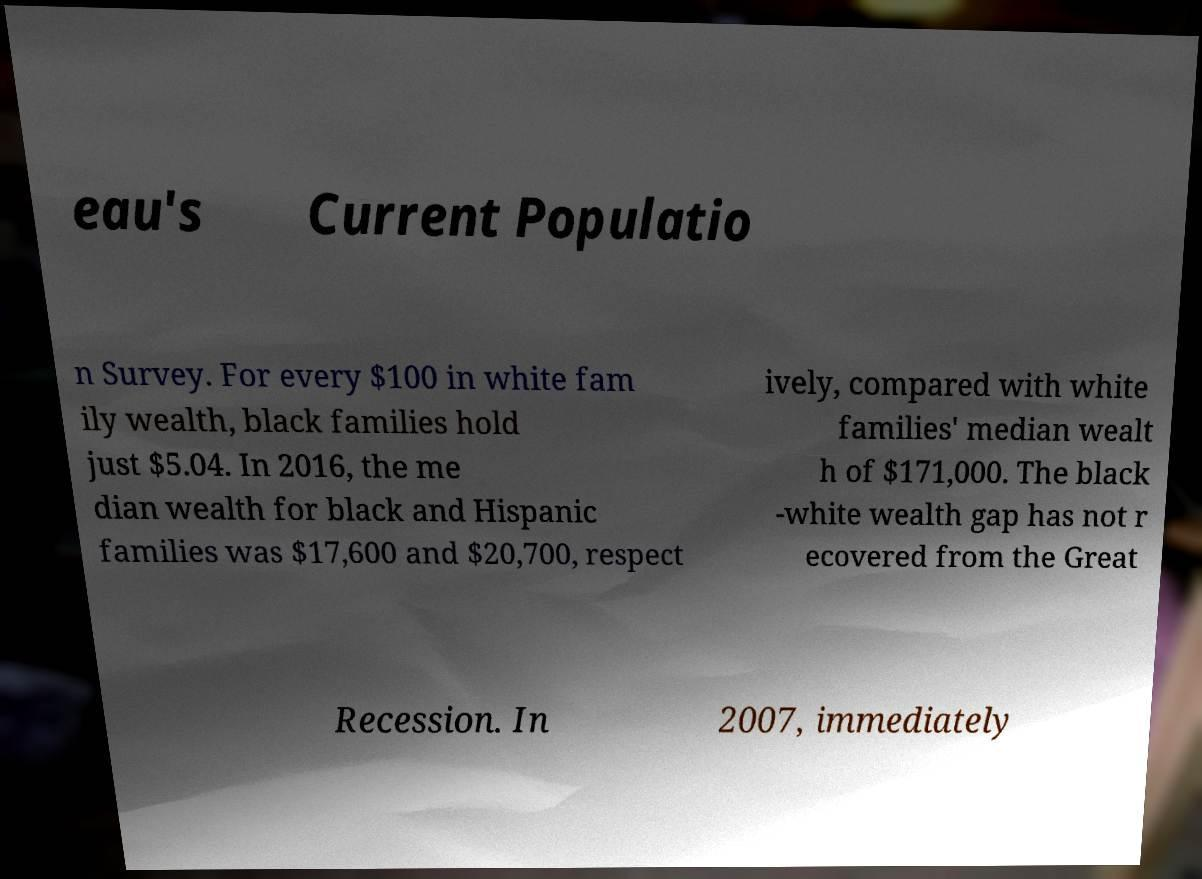What messages or text are displayed in this image? I need them in a readable, typed format. eau's Current Populatio n Survey. For every $100 in white fam ily wealth, black families hold just $5.04. In 2016, the me dian wealth for black and Hispanic families was $17,600 and $20,700, respect ively, compared with white families' median wealt h of $171,000. The black -white wealth gap has not r ecovered from the Great Recession. In 2007, immediately 